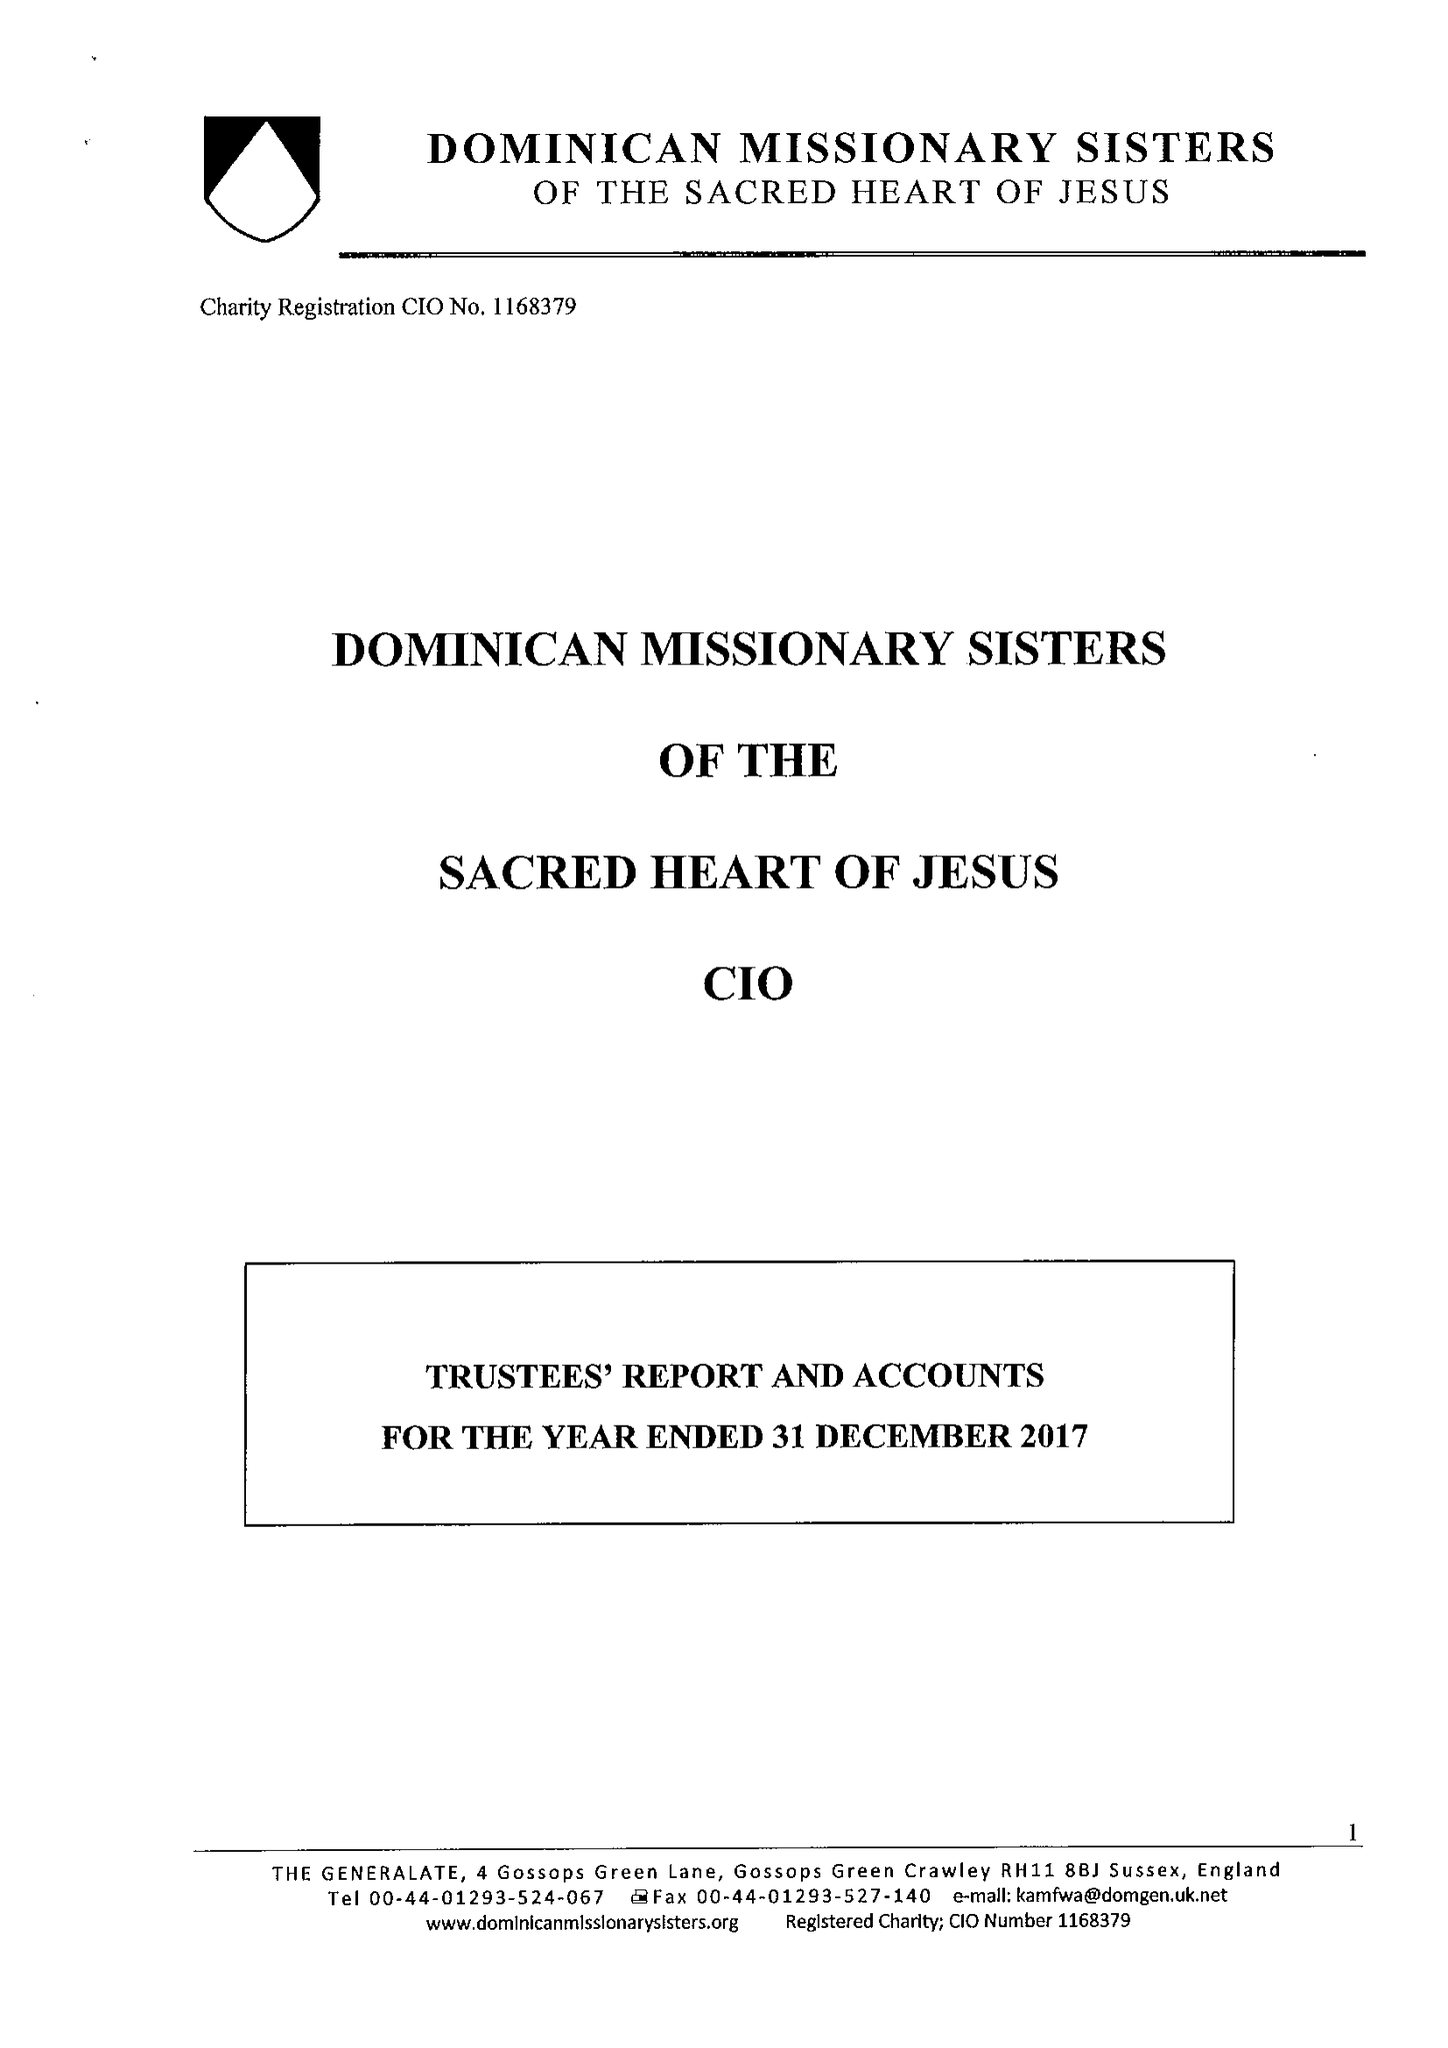What is the value for the income_annually_in_british_pounds?
Answer the question using a single word or phrase. 120014.00 